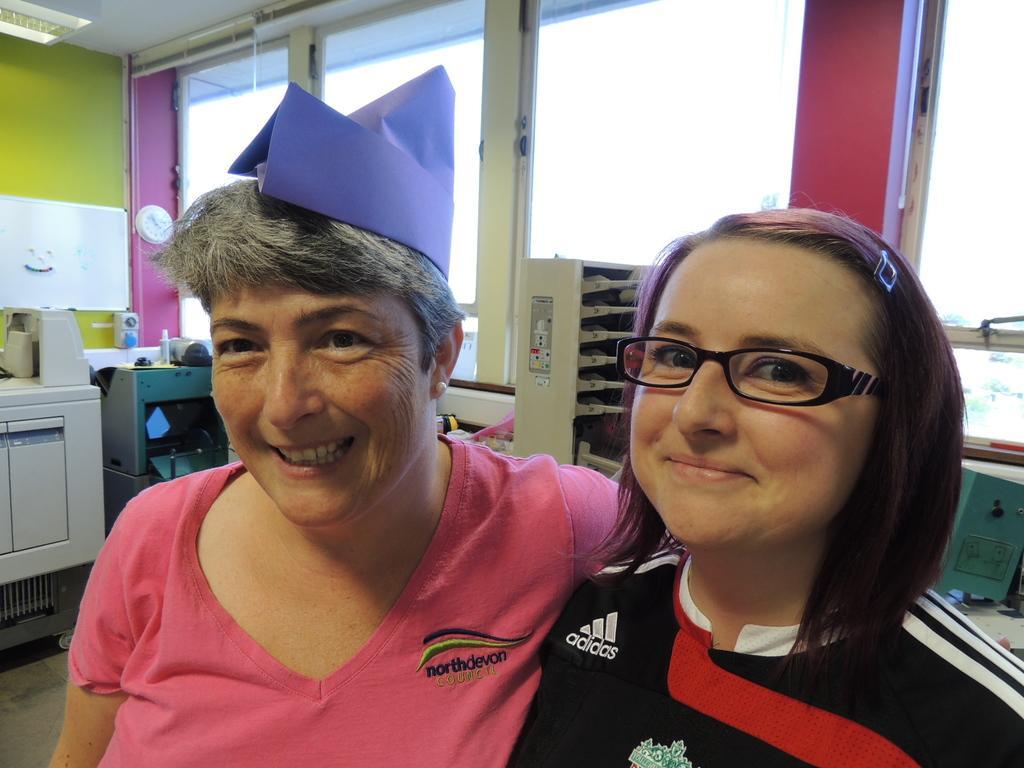How would you summarize this image in a sentence or two? There is a lady wearing pink dress and there is a violet color object on her head and there is another lady standing beside her and there are few other objects in the background. 